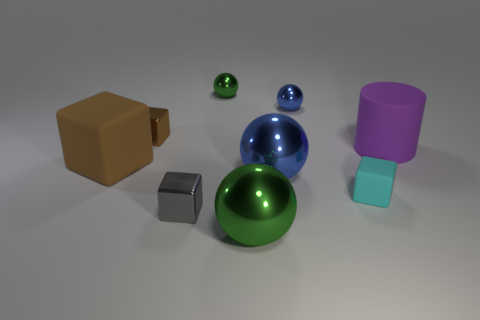Subtract all cyan blocks. How many blocks are left? 3 Subtract 2 blocks. How many blocks are left? 2 Subtract all large green balls. How many balls are left? 3 Subtract all green cubes. Subtract all green spheres. How many cubes are left? 4 Subtract all cylinders. How many objects are left? 8 Add 7 large matte cylinders. How many large matte cylinders are left? 8 Add 6 large blue rubber balls. How many large blue rubber balls exist? 6 Subtract 1 brown blocks. How many objects are left? 8 Subtract all tiny things. Subtract all small cubes. How many objects are left? 1 